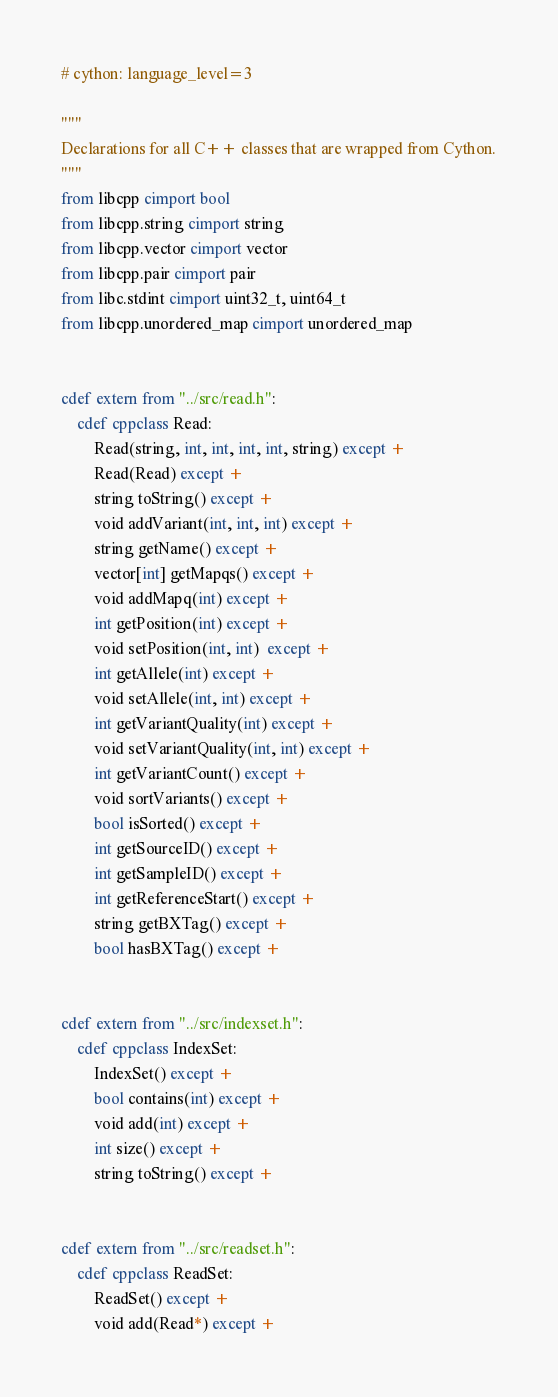<code> <loc_0><loc_0><loc_500><loc_500><_Cython_># cython: language_level=3

"""
Declarations for all C++ classes that are wrapped from Cython.
"""
from libcpp cimport bool
from libcpp.string cimport string
from libcpp.vector cimport vector
from libcpp.pair cimport pair
from libc.stdint cimport uint32_t, uint64_t
from libcpp.unordered_map cimport unordered_map


cdef extern from "../src/read.h":
	cdef cppclass Read:
		Read(string, int, int, int, int, string) except +
		Read(Read) except +
		string toString() except +
		void addVariant(int, int, int) except +
		string getName() except +
		vector[int] getMapqs() except +
		void addMapq(int) except +
		int getPosition(int) except +
		void setPosition(int, int)  except +
		int getAllele(int) except +
		void setAllele(int, int) except +
		int getVariantQuality(int) except +
		void setVariantQuality(int, int) except +
		int getVariantCount() except +
		void sortVariants() except +
		bool isSorted() except +
		int getSourceID() except +
		int getSampleID() except +
		int getReferenceStart() except +
		string getBXTag() except +
		bool hasBXTag() except +


cdef extern from "../src/indexset.h":
	cdef cppclass IndexSet:
		IndexSet() except +
		bool contains(int) except +
		void add(int) except +
		int size() except +
		string toString() except +


cdef extern from "../src/readset.h":
	cdef cppclass ReadSet:
		ReadSet() except +
		void add(Read*) except +</code> 